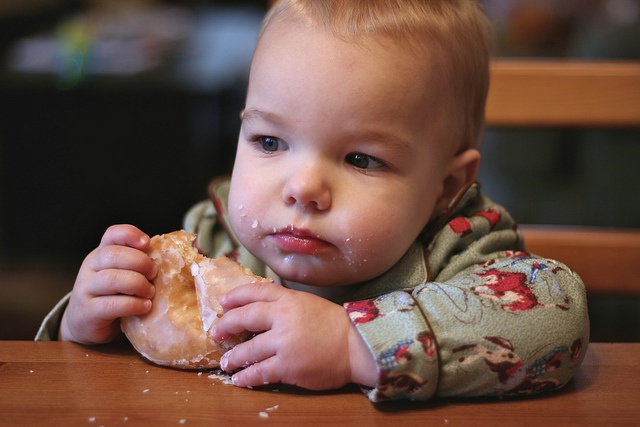Describe the objects in this image and their specific colors. I can see people in black, maroon, brown, and lightpink tones, dining table in black, brown, and maroon tones, chair in black, brown, and maroon tones, and donut in black, tan, salmon, and brown tones in this image. 